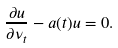<formula> <loc_0><loc_0><loc_500><loc_500>\frac { \partial u } { \partial \nu _ { t } } - a ( t ) u = 0 .</formula> 